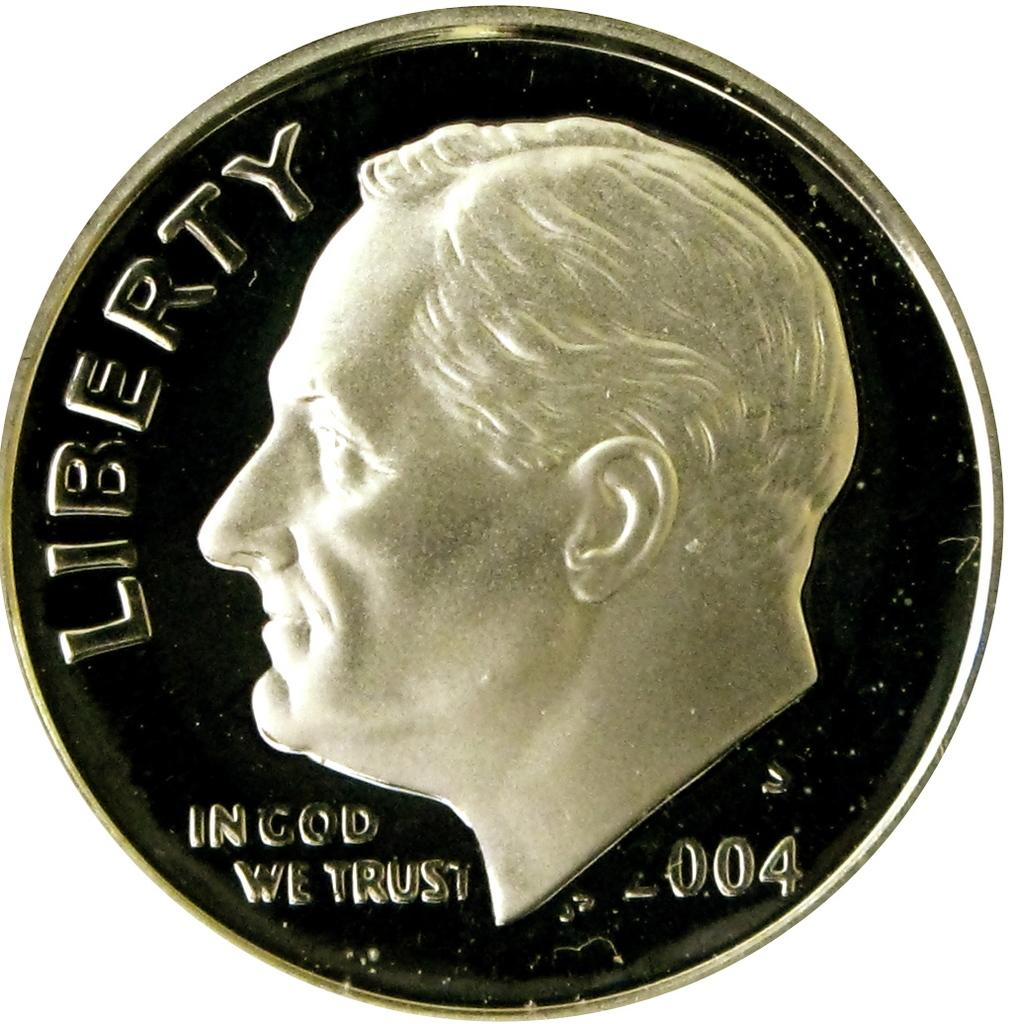<image>
Present a compact description of the photo's key features. a 2004 coin with a man and the word Liberty on it 